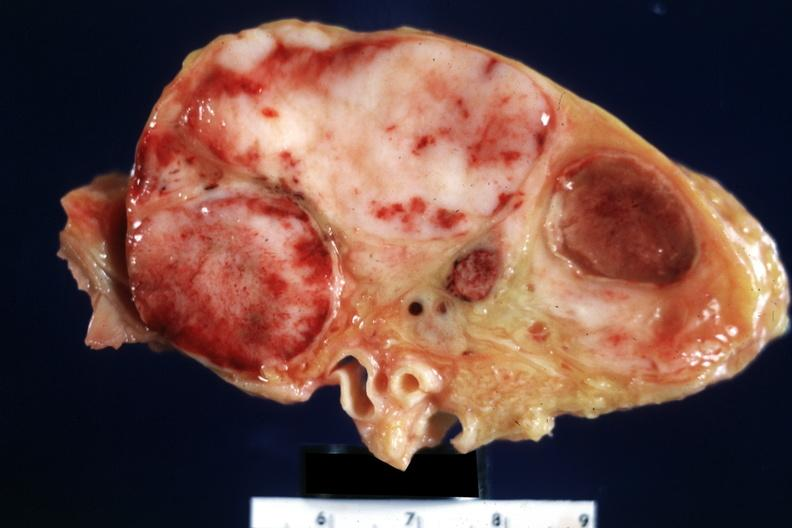what does this image show?
Answer the question using a single word or phrase. Excellent close-up of enlarged inguinal nodes with white tumor and areas of hemorrhagic necrosis 